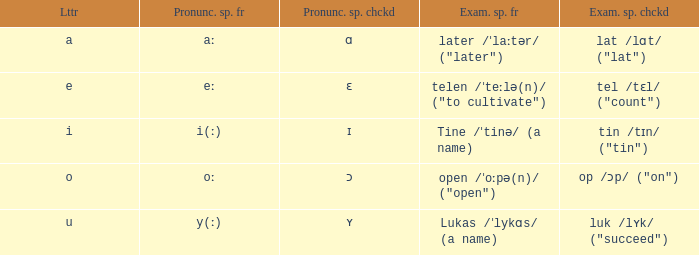What is Pronunciation Spelled Free, when Pronunciation Spelled Checked is "ɛ"? Eː. 